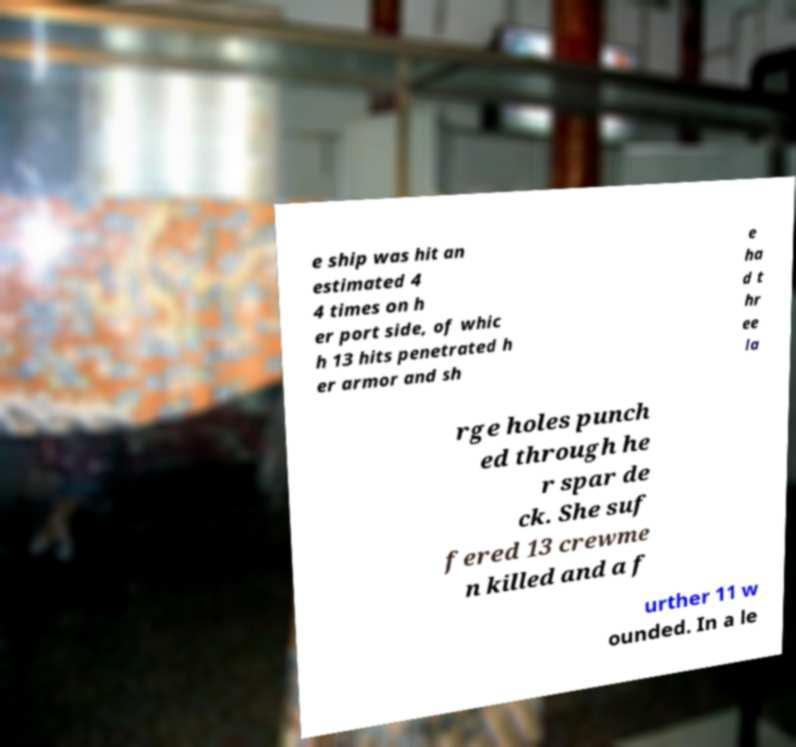I need the written content from this picture converted into text. Can you do that? e ship was hit an estimated 4 4 times on h er port side, of whic h 13 hits penetrated h er armor and sh e ha d t hr ee la rge holes punch ed through he r spar de ck. She suf fered 13 crewme n killed and a f urther 11 w ounded. In a le 